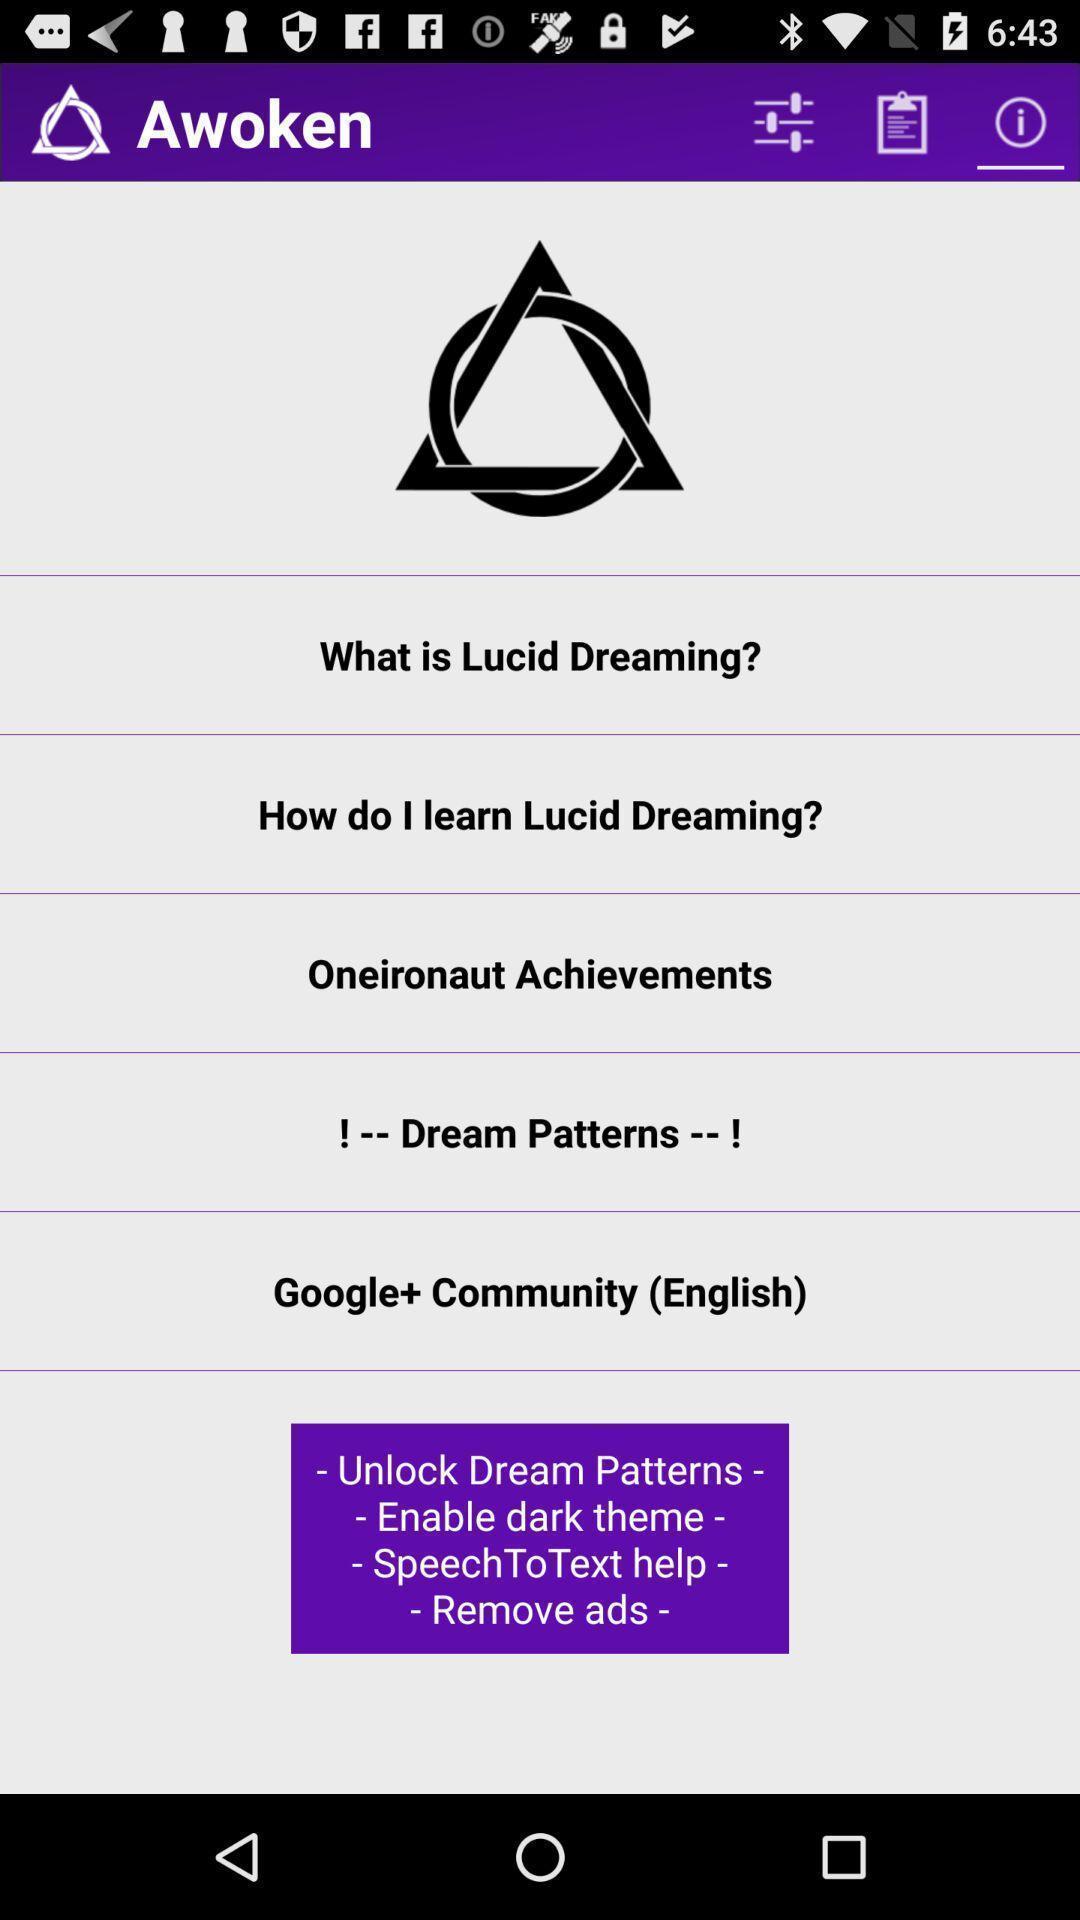Explain the elements present in this screenshot. Screen showing learning page. 